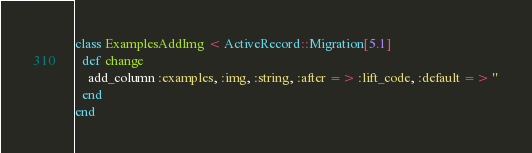Convert code to text. <code><loc_0><loc_0><loc_500><loc_500><_Ruby_>class ExamplesAddImg < ActiveRecord::Migration[5.1]
  def change
    add_column :examples, :img, :string, :after => :lift_code, :default => ''
  end
end
</code> 